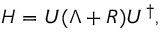Convert formula to latex. <formula><loc_0><loc_0><loc_500><loc_500>H = U ( \Lambda + R ) U ^ { \dag } ,</formula> 